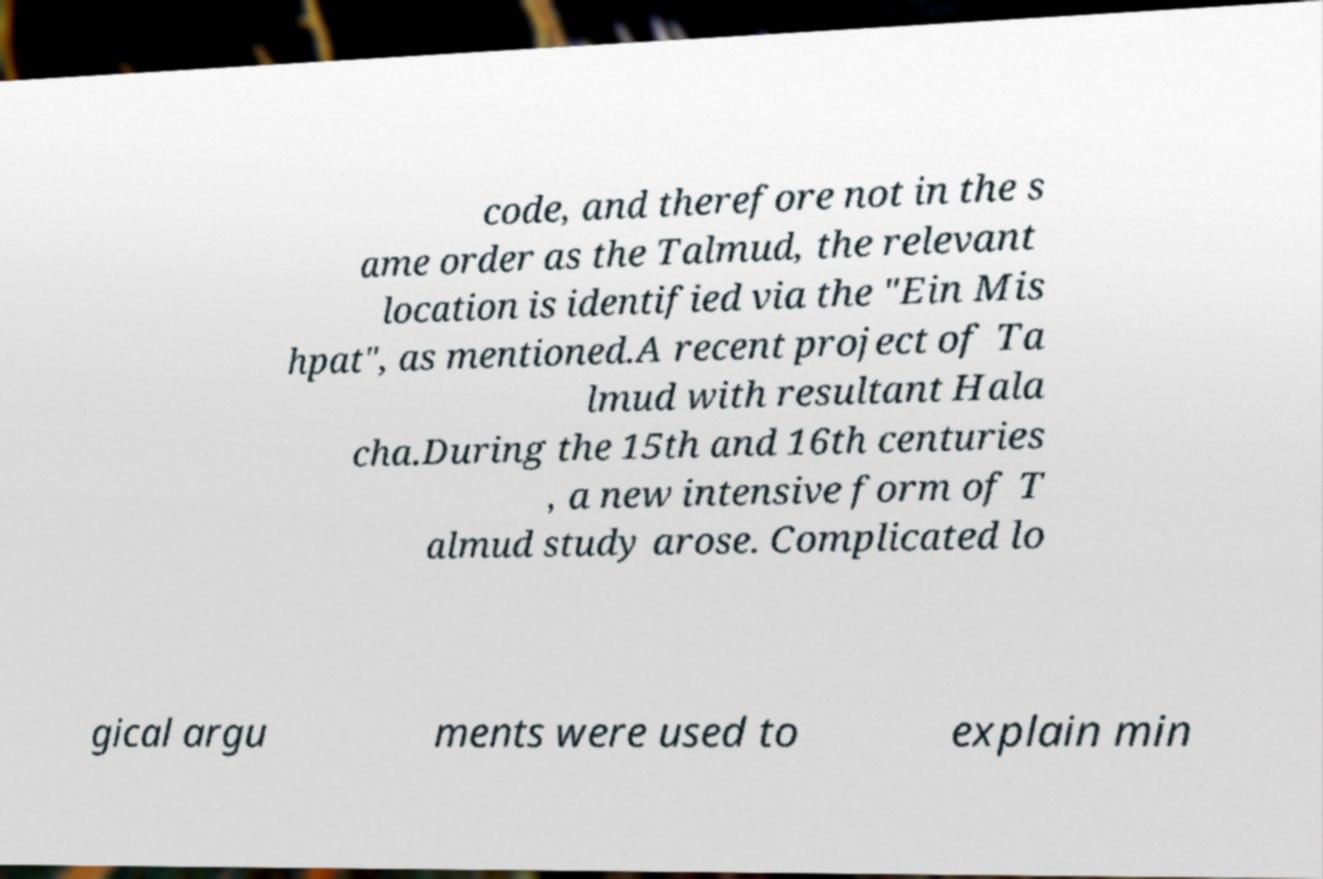I need the written content from this picture converted into text. Can you do that? code, and therefore not in the s ame order as the Talmud, the relevant location is identified via the "Ein Mis hpat", as mentioned.A recent project of Ta lmud with resultant Hala cha.During the 15th and 16th centuries , a new intensive form of T almud study arose. Complicated lo gical argu ments were used to explain min 